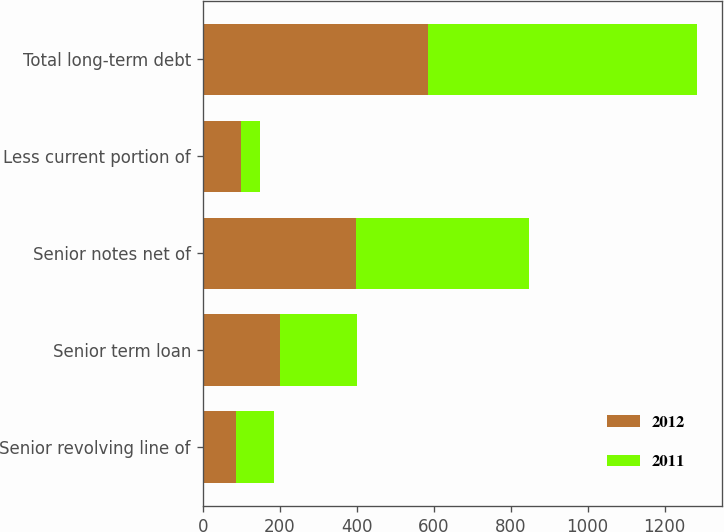<chart> <loc_0><loc_0><loc_500><loc_500><stacked_bar_chart><ecel><fcel>Senior revolving line of<fcel>Senior term loan<fcel>Senior notes net of<fcel>Less current portion of<fcel>Total long-term debt<nl><fcel>2012<fcel>85.8<fcel>200<fcel>399.5<fcel>100<fcel>585.3<nl><fcel>2011<fcel>99.8<fcel>200<fcel>449.4<fcel>50<fcel>699.2<nl></chart> 